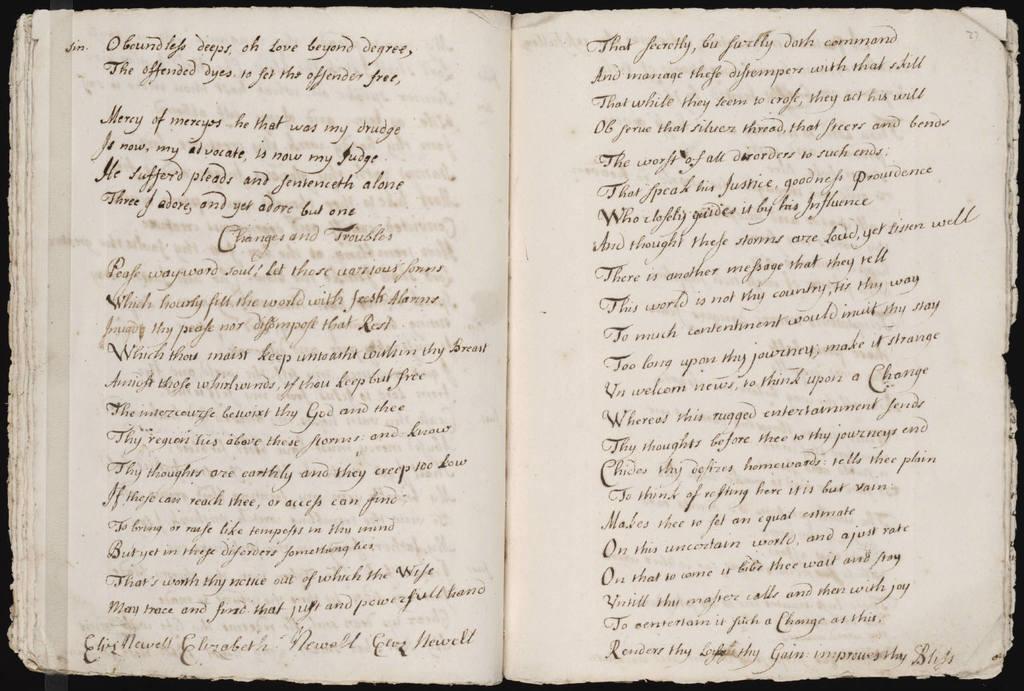How would you summarize this image in a sentence or two? It is a closed picture of a book. Black color text lines and black borders are visible in this image. 